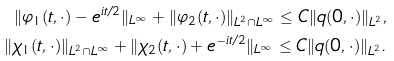Convert formula to latex. <formula><loc_0><loc_0><loc_500><loc_500>\| \varphi _ { 1 } ( t , \cdot ) - e ^ { i t / 2 } \| _ { L ^ { \infty } } + \| \varphi _ { 2 } ( t , \cdot ) \| _ { L ^ { 2 } \cap L ^ { \infty } } \leq C \| q ( 0 , \cdot ) \| _ { L ^ { 2 } } , \\ \| \chi _ { 1 } ( t , \cdot ) \| _ { L ^ { 2 } \cap L ^ { \infty } } + \| \chi _ { 2 } ( t , \cdot ) + e ^ { - i t / 2 } \| _ { L ^ { \infty } } \leq C \| q ( 0 , \cdot ) \| _ { L ^ { 2 } } .</formula> 